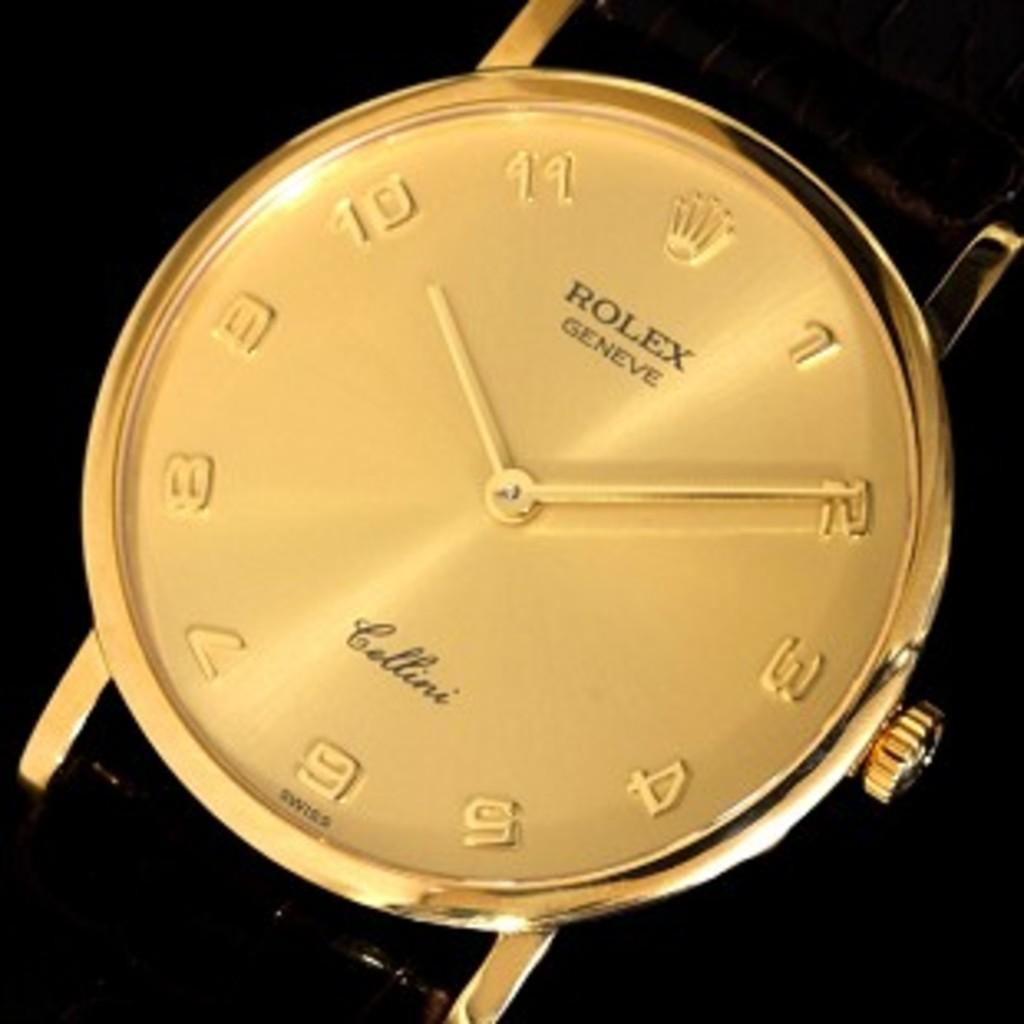<image>
Share a concise interpretation of the image provided. A gold Rolex Geneve watch with the word Cellini on it. 